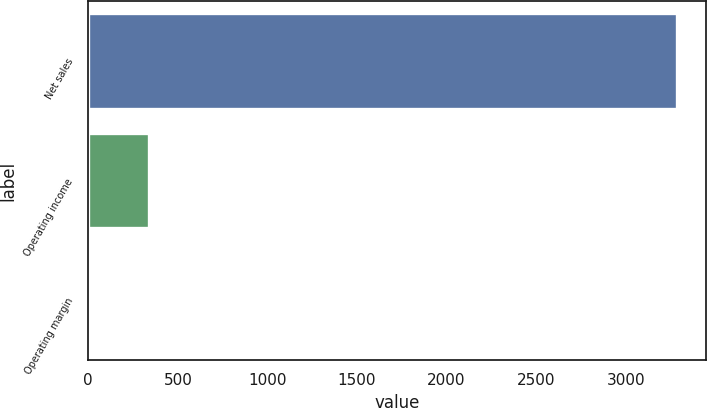<chart> <loc_0><loc_0><loc_500><loc_500><bar_chart><fcel>Net sales<fcel>Operating income<fcel>Operating margin<nl><fcel>3285<fcel>337.68<fcel>10.2<nl></chart> 